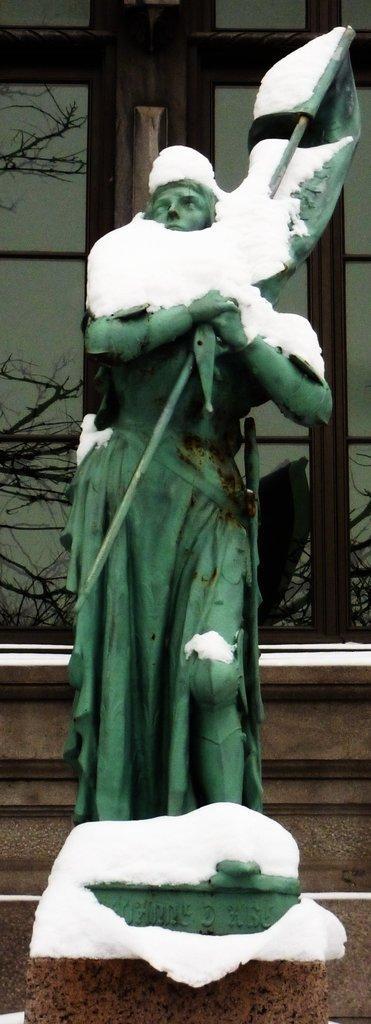In one or two sentences, can you explain what this image depicts? In the image I can see the sculpture of a person. On the sculpture I can see the snow. In the background I can see trees and some other objects. 